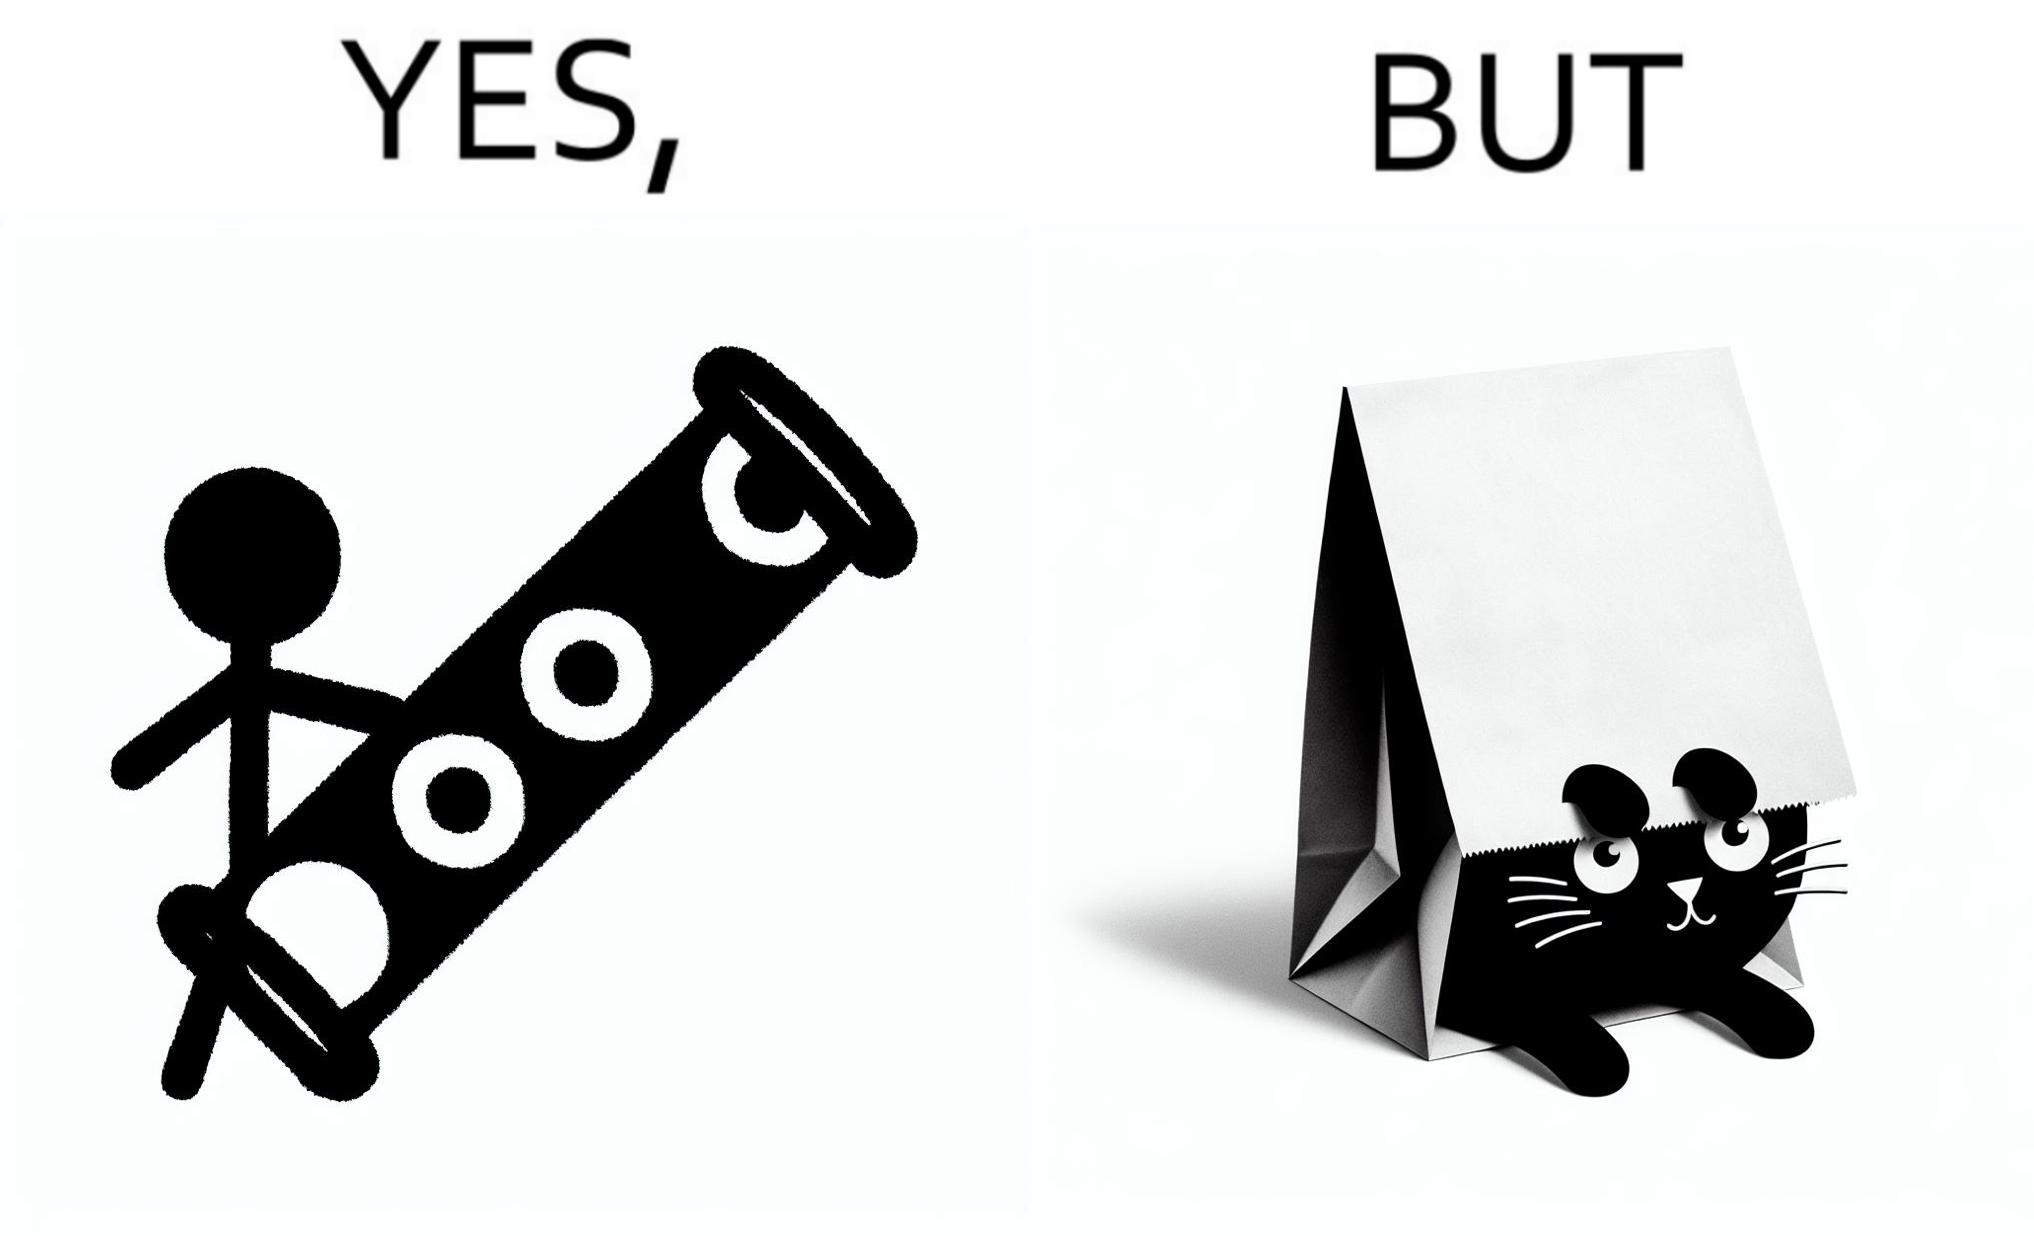What is the satirical meaning behind this image? The image is funny, because even when there is a dedicated thing for the animal to play with it still is hiding itself in the paper bag 